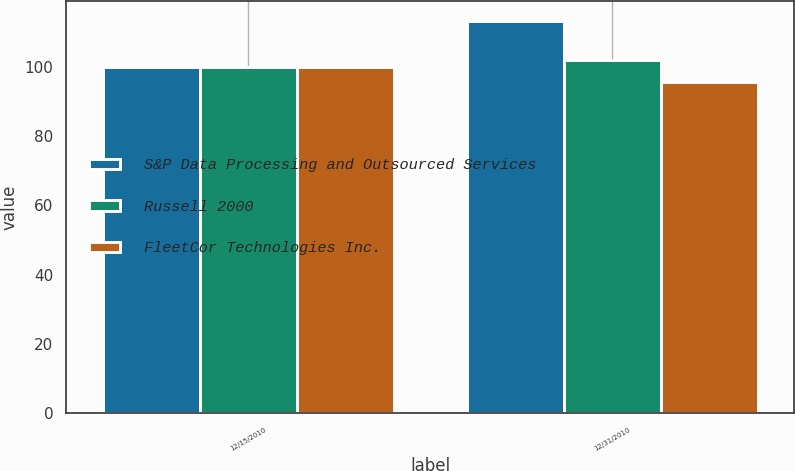<chart> <loc_0><loc_0><loc_500><loc_500><stacked_bar_chart><ecel><fcel>12/15/2010<fcel>12/31/2010<nl><fcel>S&P Data Processing and Outsourced Services<fcel>100<fcel>113.47<nl><fcel>Russell 2000<fcel>100<fcel>101.99<nl><fcel>FleetCor Technologies Inc.<fcel>100<fcel>95.81<nl></chart> 